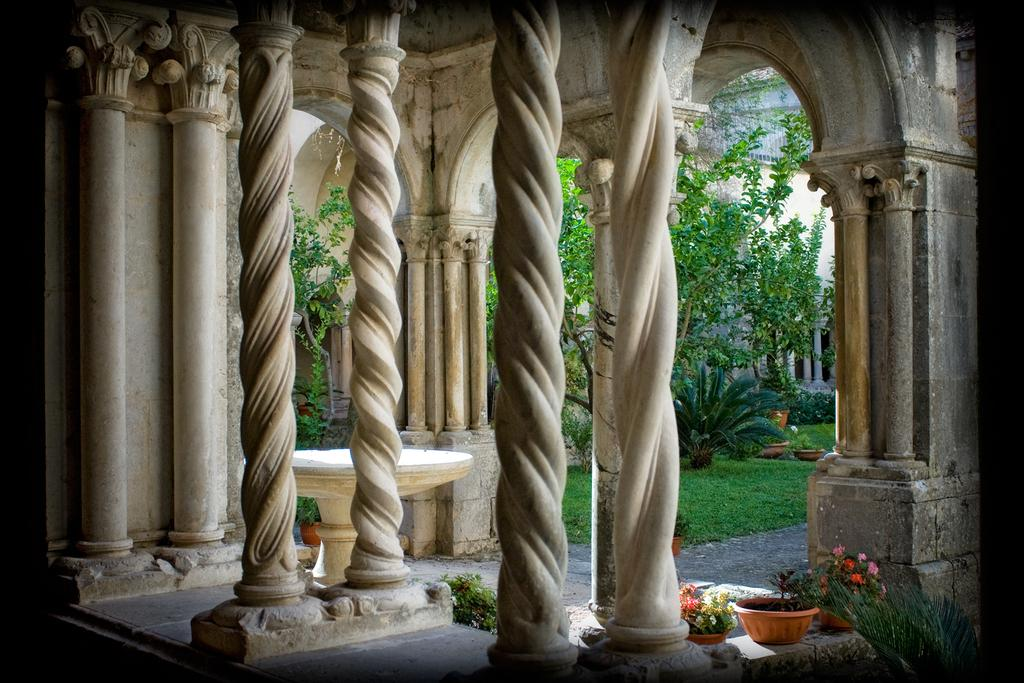What architectural features can be seen in the image? There are pillars in the image. What type of vegetation is placed on the floor in the image? There are plants placed on the floor in the image. What type of ground cover is visible in the image? There is grass visible on the ground in the image. What can be seen in the background of the image? There are trees and a building in the background of the image. What type of bird is perched on the pipe in the image? There is no bird or pipe present in the image. 